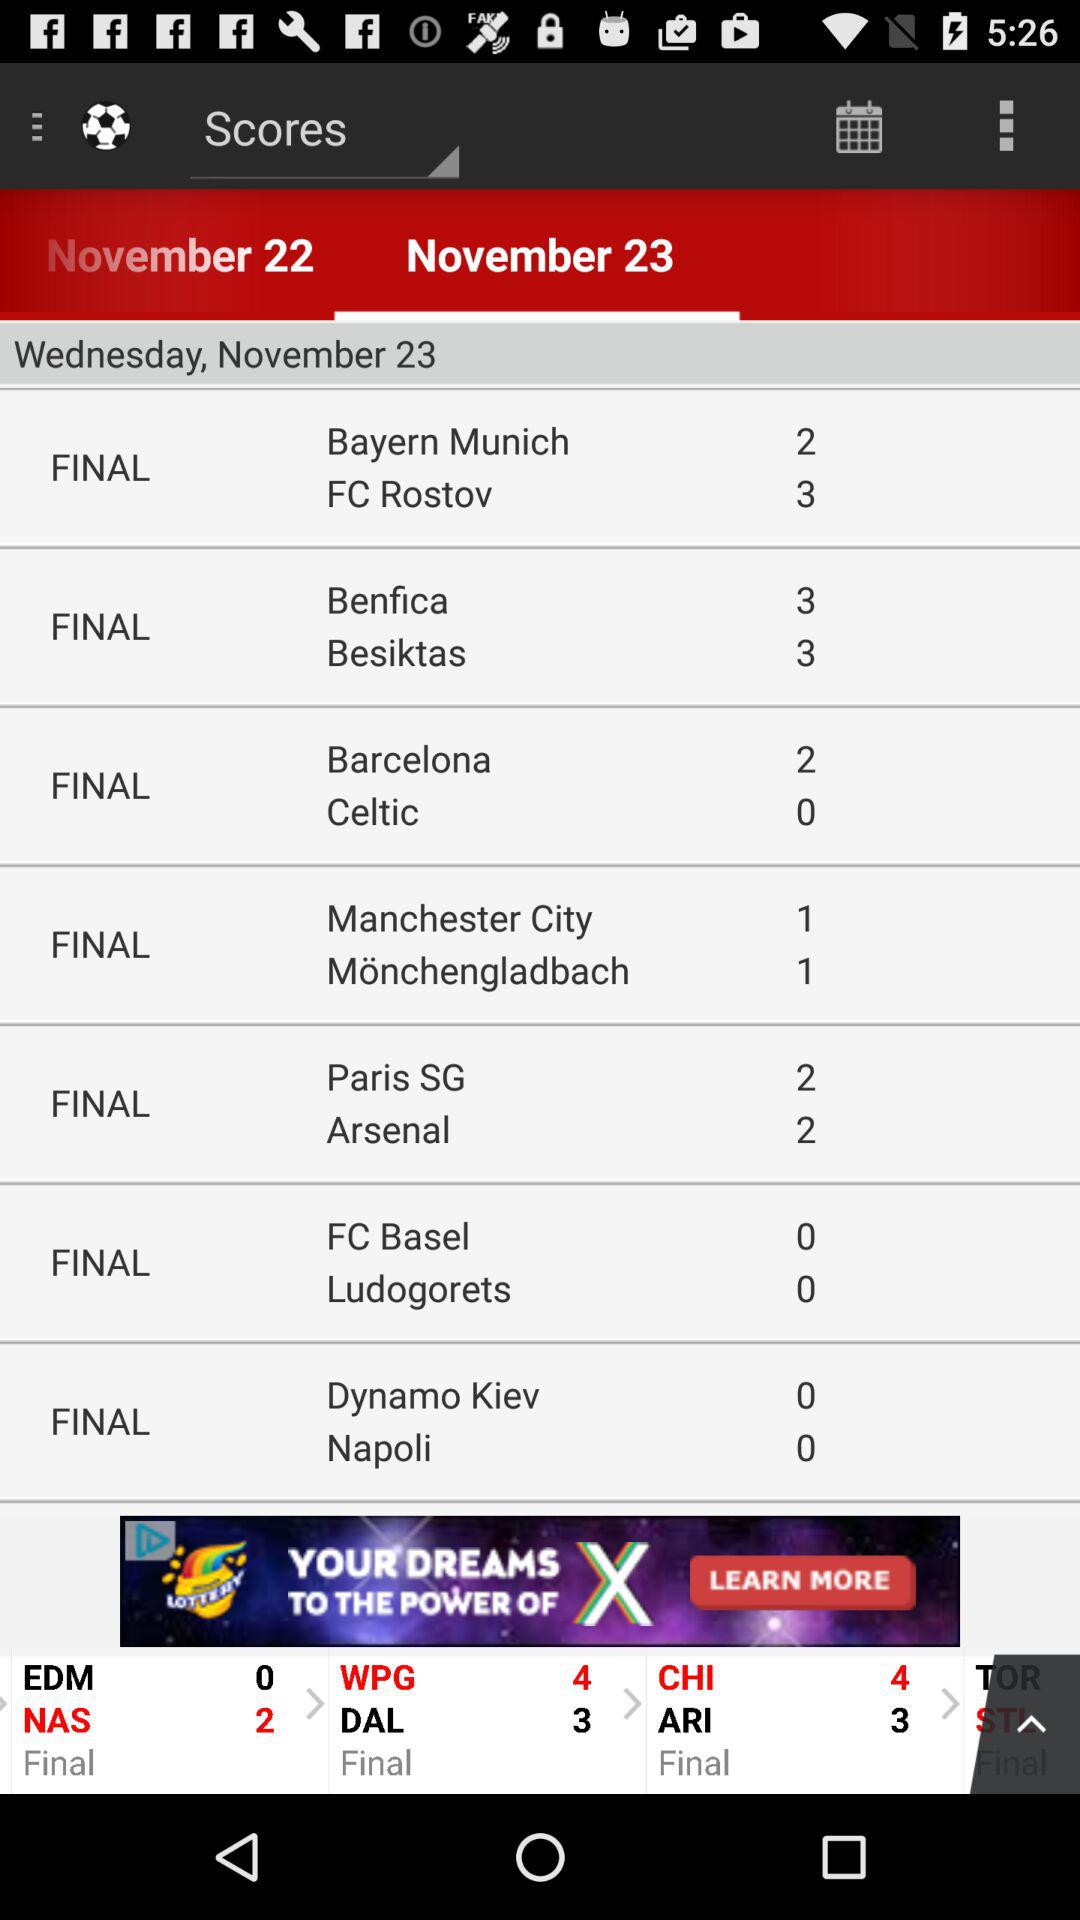Which teams have the highest score and a tie among them?
When the provided information is insufficient, respond with <no answer>. <no answer> 